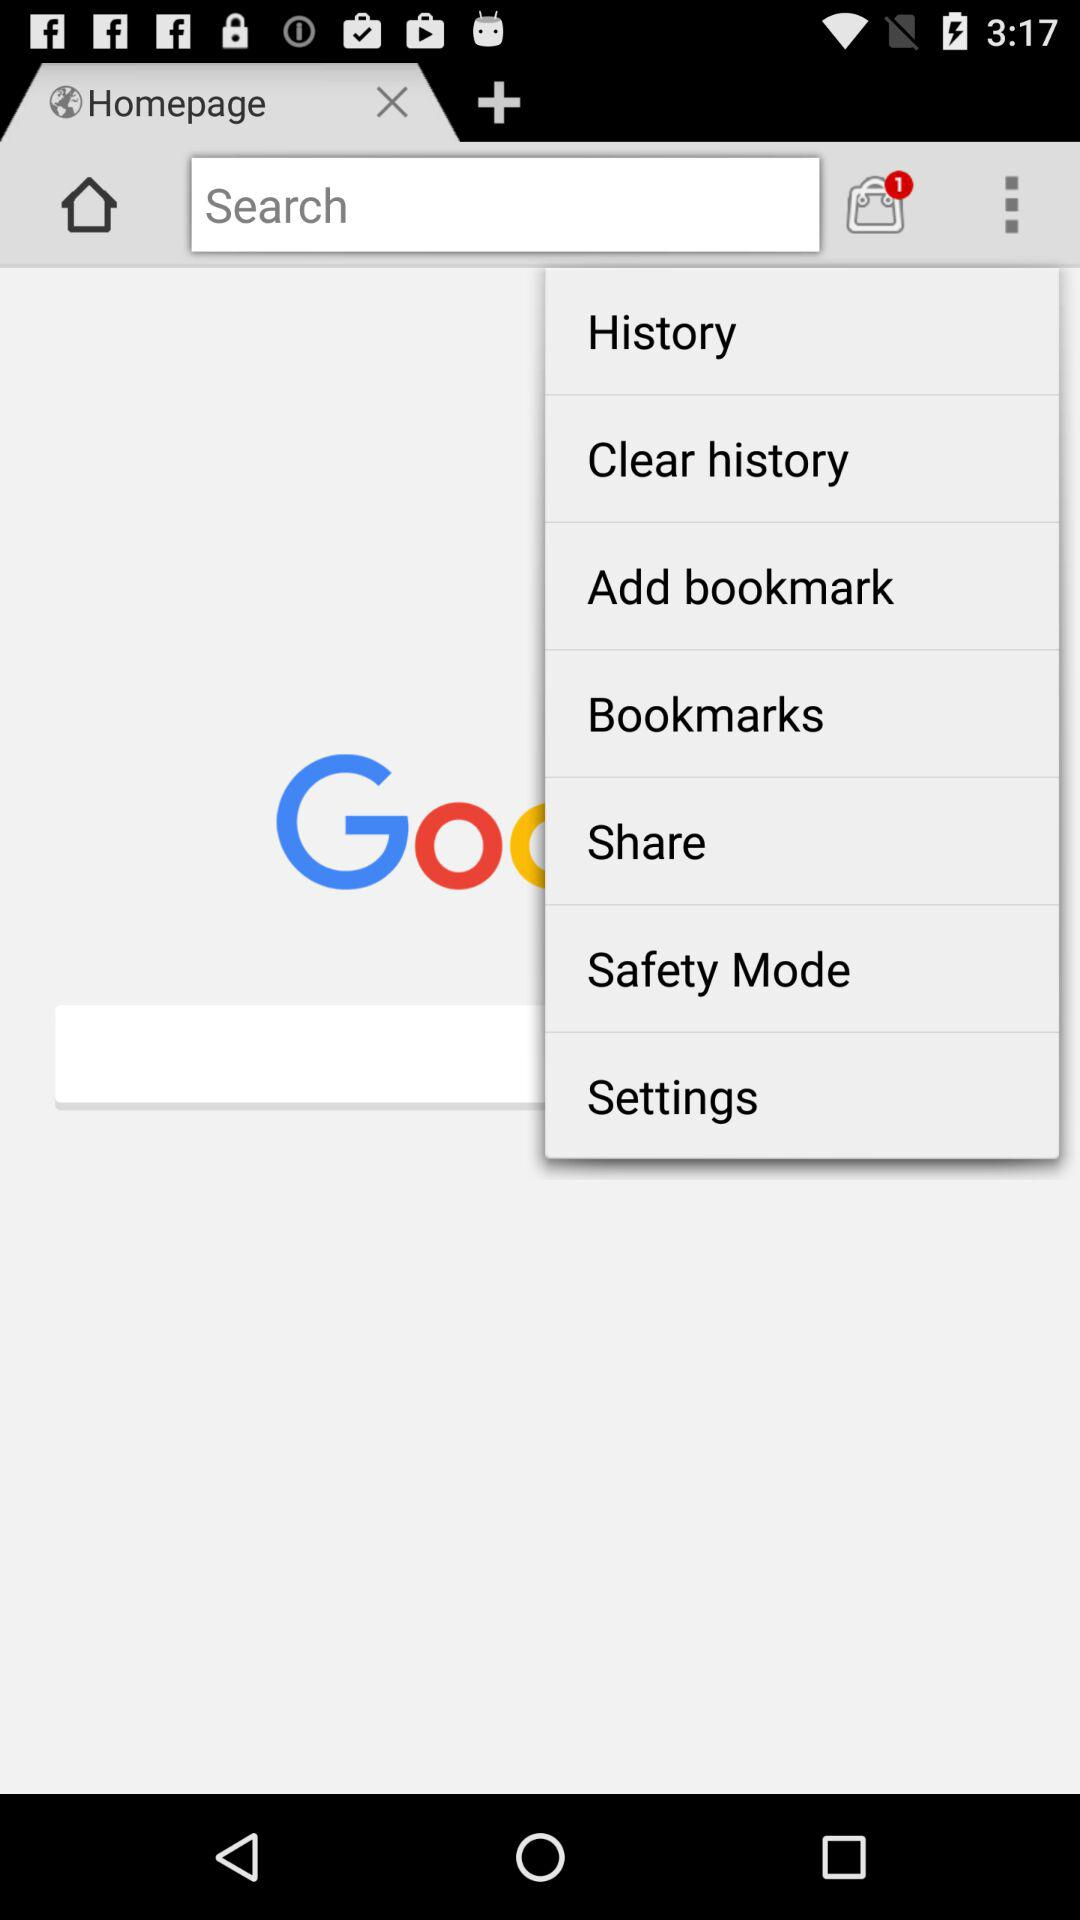How many shopping bags are there on the screen?
Answer the question using a single word or phrase. 1 